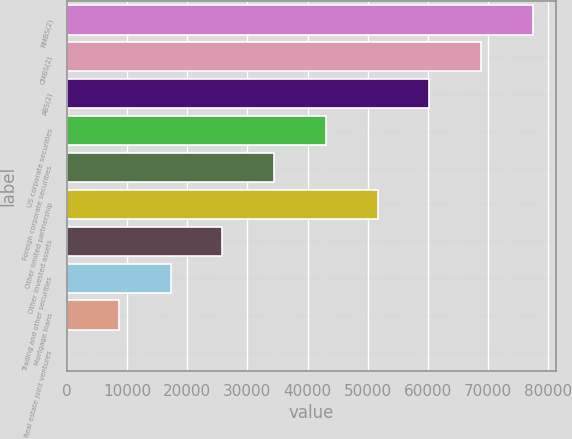Convert chart to OTSL. <chart><loc_0><loc_0><loc_500><loc_500><bar_chart><fcel>RMBS(2)<fcel>CMBS(2)<fcel>ABS(2)<fcel>US corporate securities<fcel>Foreign corporate securities<fcel>Other limited partnership<fcel>Other invested assets<fcel>Trading and other securities<fcel>Mortgage loans<fcel>Real estate joint ventures<nl><fcel>77415.1<fcel>68820.2<fcel>60225.3<fcel>43035.5<fcel>34440.6<fcel>51630.4<fcel>25845.7<fcel>17250.8<fcel>8655.9<fcel>61<nl></chart> 